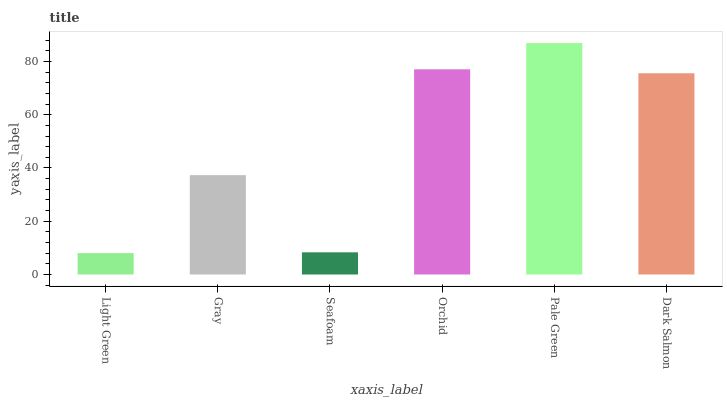Is Gray the minimum?
Answer yes or no. No. Is Gray the maximum?
Answer yes or no. No. Is Gray greater than Light Green?
Answer yes or no. Yes. Is Light Green less than Gray?
Answer yes or no. Yes. Is Light Green greater than Gray?
Answer yes or no. No. Is Gray less than Light Green?
Answer yes or no. No. Is Dark Salmon the high median?
Answer yes or no. Yes. Is Gray the low median?
Answer yes or no. Yes. Is Gray the high median?
Answer yes or no. No. Is Orchid the low median?
Answer yes or no. No. 